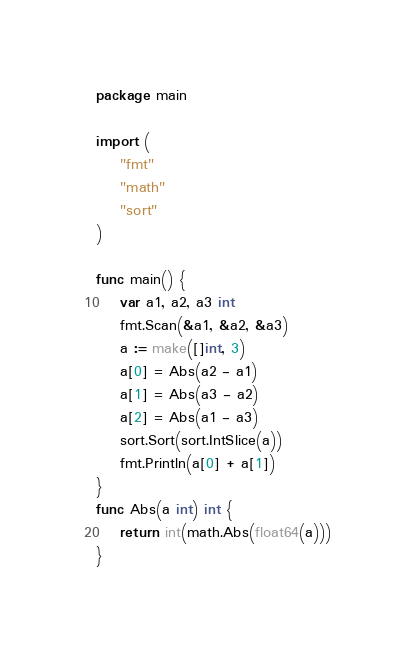Convert code to text. <code><loc_0><loc_0><loc_500><loc_500><_Go_>package main

import (
	"fmt"
	"math"
	"sort"
)

func main() {
	var a1, a2, a3 int
	fmt.Scan(&a1, &a2, &a3)
	a := make([]int, 3)
	a[0] = Abs(a2 - a1)
	a[1] = Abs(a3 - a2)
	a[2] = Abs(a1 - a3)
	sort.Sort(sort.IntSlice(a))
	fmt.Println(a[0] + a[1])
}
func Abs(a int) int {
	return int(math.Abs(float64(a)))
}

</code> 